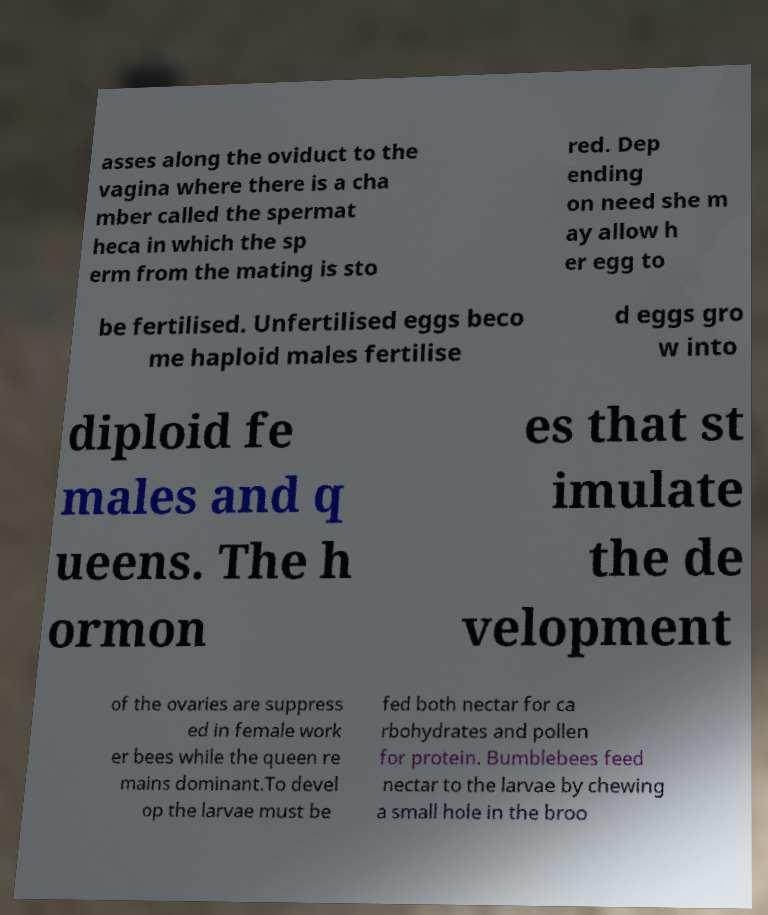Could you extract and type out the text from this image? asses along the oviduct to the vagina where there is a cha mber called the spermat heca in which the sp erm from the mating is sto red. Dep ending on need she m ay allow h er egg to be fertilised. Unfertilised eggs beco me haploid males fertilise d eggs gro w into diploid fe males and q ueens. The h ormon es that st imulate the de velopment of the ovaries are suppress ed in female work er bees while the queen re mains dominant.To devel op the larvae must be fed both nectar for ca rbohydrates and pollen for protein. Bumblebees feed nectar to the larvae by chewing a small hole in the broo 